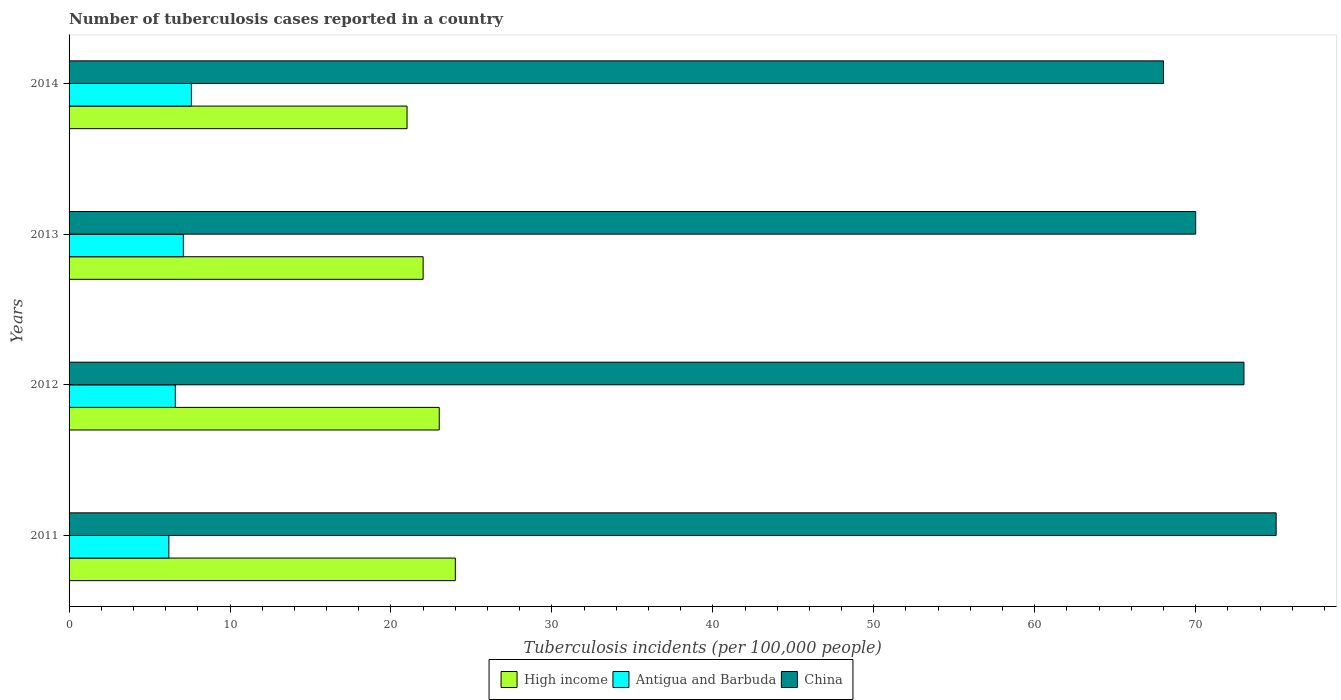How many different coloured bars are there?
Your response must be concise. 3. Are the number of bars per tick equal to the number of legend labels?
Give a very brief answer. Yes. Are the number of bars on each tick of the Y-axis equal?
Your answer should be very brief. Yes. How many bars are there on the 1st tick from the bottom?
Ensure brevity in your answer.  3. What is the label of the 2nd group of bars from the top?
Your answer should be very brief. 2013. What is the number of tuberculosis cases reported in in High income in 2012?
Your answer should be very brief. 23. Across all years, what is the maximum number of tuberculosis cases reported in in Antigua and Barbuda?
Ensure brevity in your answer.  7.6. Across all years, what is the minimum number of tuberculosis cases reported in in High income?
Your response must be concise. 21. In which year was the number of tuberculosis cases reported in in High income minimum?
Offer a terse response. 2014. What is the total number of tuberculosis cases reported in in China in the graph?
Make the answer very short. 286. What is the difference between the number of tuberculosis cases reported in in China in 2011 and that in 2014?
Your answer should be very brief. 7. What is the difference between the number of tuberculosis cases reported in in Antigua and Barbuda in 2011 and the number of tuberculosis cases reported in in China in 2012?
Your answer should be compact. -66.8. What is the average number of tuberculosis cases reported in in Antigua and Barbuda per year?
Keep it short and to the point. 6.88. In the year 2011, what is the difference between the number of tuberculosis cases reported in in China and number of tuberculosis cases reported in in Antigua and Barbuda?
Offer a very short reply. 68.8. In how many years, is the number of tuberculosis cases reported in in China greater than 30 ?
Provide a succinct answer. 4. What is the ratio of the number of tuberculosis cases reported in in Antigua and Barbuda in 2011 to that in 2013?
Give a very brief answer. 0.87. What is the difference between the highest and the second highest number of tuberculosis cases reported in in Antigua and Barbuda?
Offer a terse response. 0.5. What is the difference between the highest and the lowest number of tuberculosis cases reported in in Antigua and Barbuda?
Make the answer very short. 1.4. In how many years, is the number of tuberculosis cases reported in in Antigua and Barbuda greater than the average number of tuberculosis cases reported in in Antigua and Barbuda taken over all years?
Offer a terse response. 2. Is the sum of the number of tuberculosis cases reported in in Antigua and Barbuda in 2011 and 2012 greater than the maximum number of tuberculosis cases reported in in High income across all years?
Offer a terse response. No. What does the 3rd bar from the top in 2014 represents?
Keep it short and to the point. High income. Is it the case that in every year, the sum of the number of tuberculosis cases reported in in China and number of tuberculosis cases reported in in High income is greater than the number of tuberculosis cases reported in in Antigua and Barbuda?
Offer a terse response. Yes. How many bars are there?
Provide a short and direct response. 12. How many years are there in the graph?
Give a very brief answer. 4. What is the difference between two consecutive major ticks on the X-axis?
Your answer should be very brief. 10. How are the legend labels stacked?
Provide a short and direct response. Horizontal. What is the title of the graph?
Your answer should be very brief. Number of tuberculosis cases reported in a country. What is the label or title of the X-axis?
Keep it short and to the point. Tuberculosis incidents (per 100,0 people). What is the label or title of the Y-axis?
Provide a short and direct response. Years. What is the Tuberculosis incidents (per 100,000 people) in Antigua and Barbuda in 2011?
Your answer should be very brief. 6.2. What is the Tuberculosis incidents (per 100,000 people) of High income in 2012?
Provide a succinct answer. 23. What is the Tuberculosis incidents (per 100,000 people) in China in 2012?
Make the answer very short. 73. What is the Tuberculosis incidents (per 100,000 people) in Antigua and Barbuda in 2013?
Keep it short and to the point. 7.1. What is the Tuberculosis incidents (per 100,000 people) of High income in 2014?
Provide a short and direct response. 21. What is the Tuberculosis incidents (per 100,000 people) in Antigua and Barbuda in 2014?
Offer a very short reply. 7.6. What is the Tuberculosis incidents (per 100,000 people) in China in 2014?
Give a very brief answer. 68. Across all years, what is the minimum Tuberculosis incidents (per 100,000 people) in High income?
Offer a very short reply. 21. What is the total Tuberculosis incidents (per 100,000 people) of China in the graph?
Ensure brevity in your answer.  286. What is the difference between the Tuberculosis incidents (per 100,000 people) in Antigua and Barbuda in 2011 and that in 2012?
Your answer should be compact. -0.4. What is the difference between the Tuberculosis incidents (per 100,000 people) in Antigua and Barbuda in 2011 and that in 2013?
Give a very brief answer. -0.9. What is the difference between the Tuberculosis incidents (per 100,000 people) in High income in 2011 and that in 2014?
Your answer should be very brief. 3. What is the difference between the Tuberculosis incidents (per 100,000 people) of China in 2011 and that in 2014?
Give a very brief answer. 7. What is the difference between the Tuberculosis incidents (per 100,000 people) in Antigua and Barbuda in 2012 and that in 2013?
Provide a short and direct response. -0.5. What is the difference between the Tuberculosis incidents (per 100,000 people) of High income in 2012 and that in 2014?
Make the answer very short. 2. What is the difference between the Tuberculosis incidents (per 100,000 people) in Antigua and Barbuda in 2012 and that in 2014?
Offer a very short reply. -1. What is the difference between the Tuberculosis incidents (per 100,000 people) of China in 2012 and that in 2014?
Your answer should be very brief. 5. What is the difference between the Tuberculosis incidents (per 100,000 people) of High income in 2013 and that in 2014?
Your response must be concise. 1. What is the difference between the Tuberculosis incidents (per 100,000 people) of China in 2013 and that in 2014?
Your response must be concise. 2. What is the difference between the Tuberculosis incidents (per 100,000 people) in High income in 2011 and the Tuberculosis incidents (per 100,000 people) in Antigua and Barbuda in 2012?
Provide a succinct answer. 17.4. What is the difference between the Tuberculosis incidents (per 100,000 people) in High income in 2011 and the Tuberculosis incidents (per 100,000 people) in China in 2012?
Give a very brief answer. -49. What is the difference between the Tuberculosis incidents (per 100,000 people) in Antigua and Barbuda in 2011 and the Tuberculosis incidents (per 100,000 people) in China in 2012?
Provide a succinct answer. -66.8. What is the difference between the Tuberculosis incidents (per 100,000 people) of High income in 2011 and the Tuberculosis incidents (per 100,000 people) of Antigua and Barbuda in 2013?
Your answer should be compact. 16.9. What is the difference between the Tuberculosis incidents (per 100,000 people) of High income in 2011 and the Tuberculosis incidents (per 100,000 people) of China in 2013?
Keep it short and to the point. -46. What is the difference between the Tuberculosis incidents (per 100,000 people) of Antigua and Barbuda in 2011 and the Tuberculosis incidents (per 100,000 people) of China in 2013?
Keep it short and to the point. -63.8. What is the difference between the Tuberculosis incidents (per 100,000 people) of High income in 2011 and the Tuberculosis incidents (per 100,000 people) of Antigua and Barbuda in 2014?
Offer a very short reply. 16.4. What is the difference between the Tuberculosis incidents (per 100,000 people) in High income in 2011 and the Tuberculosis incidents (per 100,000 people) in China in 2014?
Provide a succinct answer. -44. What is the difference between the Tuberculosis incidents (per 100,000 people) in Antigua and Barbuda in 2011 and the Tuberculosis incidents (per 100,000 people) in China in 2014?
Give a very brief answer. -61.8. What is the difference between the Tuberculosis incidents (per 100,000 people) in High income in 2012 and the Tuberculosis incidents (per 100,000 people) in Antigua and Barbuda in 2013?
Provide a short and direct response. 15.9. What is the difference between the Tuberculosis incidents (per 100,000 people) of High income in 2012 and the Tuberculosis incidents (per 100,000 people) of China in 2013?
Your response must be concise. -47. What is the difference between the Tuberculosis incidents (per 100,000 people) in Antigua and Barbuda in 2012 and the Tuberculosis incidents (per 100,000 people) in China in 2013?
Offer a very short reply. -63.4. What is the difference between the Tuberculosis incidents (per 100,000 people) of High income in 2012 and the Tuberculosis incidents (per 100,000 people) of Antigua and Barbuda in 2014?
Ensure brevity in your answer.  15.4. What is the difference between the Tuberculosis incidents (per 100,000 people) of High income in 2012 and the Tuberculosis incidents (per 100,000 people) of China in 2014?
Give a very brief answer. -45. What is the difference between the Tuberculosis incidents (per 100,000 people) in Antigua and Barbuda in 2012 and the Tuberculosis incidents (per 100,000 people) in China in 2014?
Ensure brevity in your answer.  -61.4. What is the difference between the Tuberculosis incidents (per 100,000 people) of High income in 2013 and the Tuberculosis incidents (per 100,000 people) of China in 2014?
Your answer should be compact. -46. What is the difference between the Tuberculosis incidents (per 100,000 people) of Antigua and Barbuda in 2013 and the Tuberculosis incidents (per 100,000 people) of China in 2014?
Make the answer very short. -60.9. What is the average Tuberculosis incidents (per 100,000 people) of Antigua and Barbuda per year?
Offer a very short reply. 6.88. What is the average Tuberculosis incidents (per 100,000 people) of China per year?
Ensure brevity in your answer.  71.5. In the year 2011, what is the difference between the Tuberculosis incidents (per 100,000 people) of High income and Tuberculosis incidents (per 100,000 people) of China?
Your answer should be very brief. -51. In the year 2011, what is the difference between the Tuberculosis incidents (per 100,000 people) in Antigua and Barbuda and Tuberculosis incidents (per 100,000 people) in China?
Your answer should be very brief. -68.8. In the year 2012, what is the difference between the Tuberculosis incidents (per 100,000 people) of High income and Tuberculosis incidents (per 100,000 people) of Antigua and Barbuda?
Your response must be concise. 16.4. In the year 2012, what is the difference between the Tuberculosis incidents (per 100,000 people) of High income and Tuberculosis incidents (per 100,000 people) of China?
Keep it short and to the point. -50. In the year 2012, what is the difference between the Tuberculosis incidents (per 100,000 people) of Antigua and Barbuda and Tuberculosis incidents (per 100,000 people) of China?
Make the answer very short. -66.4. In the year 2013, what is the difference between the Tuberculosis incidents (per 100,000 people) of High income and Tuberculosis incidents (per 100,000 people) of Antigua and Barbuda?
Offer a very short reply. 14.9. In the year 2013, what is the difference between the Tuberculosis incidents (per 100,000 people) of High income and Tuberculosis incidents (per 100,000 people) of China?
Your answer should be compact. -48. In the year 2013, what is the difference between the Tuberculosis incidents (per 100,000 people) in Antigua and Barbuda and Tuberculosis incidents (per 100,000 people) in China?
Offer a terse response. -62.9. In the year 2014, what is the difference between the Tuberculosis incidents (per 100,000 people) in High income and Tuberculosis incidents (per 100,000 people) in Antigua and Barbuda?
Keep it short and to the point. 13.4. In the year 2014, what is the difference between the Tuberculosis incidents (per 100,000 people) in High income and Tuberculosis incidents (per 100,000 people) in China?
Your response must be concise. -47. In the year 2014, what is the difference between the Tuberculosis incidents (per 100,000 people) of Antigua and Barbuda and Tuberculosis incidents (per 100,000 people) of China?
Provide a short and direct response. -60.4. What is the ratio of the Tuberculosis incidents (per 100,000 people) of High income in 2011 to that in 2012?
Your answer should be compact. 1.04. What is the ratio of the Tuberculosis incidents (per 100,000 people) in Antigua and Barbuda in 2011 to that in 2012?
Make the answer very short. 0.94. What is the ratio of the Tuberculosis incidents (per 100,000 people) in China in 2011 to that in 2012?
Keep it short and to the point. 1.03. What is the ratio of the Tuberculosis incidents (per 100,000 people) of High income in 2011 to that in 2013?
Your answer should be very brief. 1.09. What is the ratio of the Tuberculosis incidents (per 100,000 people) in Antigua and Barbuda in 2011 to that in 2013?
Offer a very short reply. 0.87. What is the ratio of the Tuberculosis incidents (per 100,000 people) in China in 2011 to that in 2013?
Give a very brief answer. 1.07. What is the ratio of the Tuberculosis incidents (per 100,000 people) of High income in 2011 to that in 2014?
Give a very brief answer. 1.14. What is the ratio of the Tuberculosis incidents (per 100,000 people) of Antigua and Barbuda in 2011 to that in 2014?
Give a very brief answer. 0.82. What is the ratio of the Tuberculosis incidents (per 100,000 people) in China in 2011 to that in 2014?
Ensure brevity in your answer.  1.1. What is the ratio of the Tuberculosis incidents (per 100,000 people) in High income in 2012 to that in 2013?
Provide a succinct answer. 1.05. What is the ratio of the Tuberculosis incidents (per 100,000 people) of Antigua and Barbuda in 2012 to that in 2013?
Keep it short and to the point. 0.93. What is the ratio of the Tuberculosis incidents (per 100,000 people) in China in 2012 to that in 2013?
Ensure brevity in your answer.  1.04. What is the ratio of the Tuberculosis incidents (per 100,000 people) in High income in 2012 to that in 2014?
Provide a succinct answer. 1.1. What is the ratio of the Tuberculosis incidents (per 100,000 people) in Antigua and Barbuda in 2012 to that in 2014?
Ensure brevity in your answer.  0.87. What is the ratio of the Tuberculosis incidents (per 100,000 people) in China in 2012 to that in 2014?
Keep it short and to the point. 1.07. What is the ratio of the Tuberculosis incidents (per 100,000 people) in High income in 2013 to that in 2014?
Provide a short and direct response. 1.05. What is the ratio of the Tuberculosis incidents (per 100,000 people) in Antigua and Barbuda in 2013 to that in 2014?
Keep it short and to the point. 0.93. What is the ratio of the Tuberculosis incidents (per 100,000 people) in China in 2013 to that in 2014?
Offer a very short reply. 1.03. What is the difference between the highest and the second highest Tuberculosis incidents (per 100,000 people) in High income?
Provide a succinct answer. 1. What is the difference between the highest and the lowest Tuberculosis incidents (per 100,000 people) in High income?
Your response must be concise. 3. What is the difference between the highest and the lowest Tuberculosis incidents (per 100,000 people) in China?
Give a very brief answer. 7. 